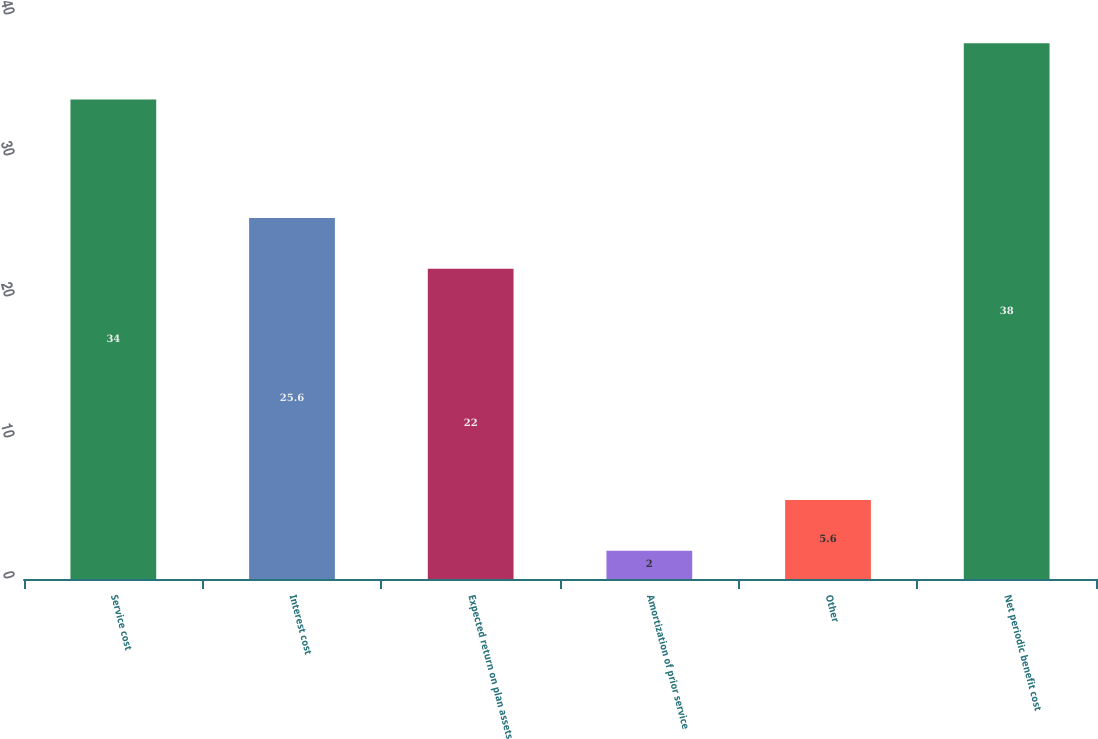Convert chart to OTSL. <chart><loc_0><loc_0><loc_500><loc_500><bar_chart><fcel>Service cost<fcel>Interest cost<fcel>Expected return on plan assets<fcel>Amortization of prior service<fcel>Other<fcel>Net periodic benefit cost<nl><fcel>34<fcel>25.6<fcel>22<fcel>2<fcel>5.6<fcel>38<nl></chart> 